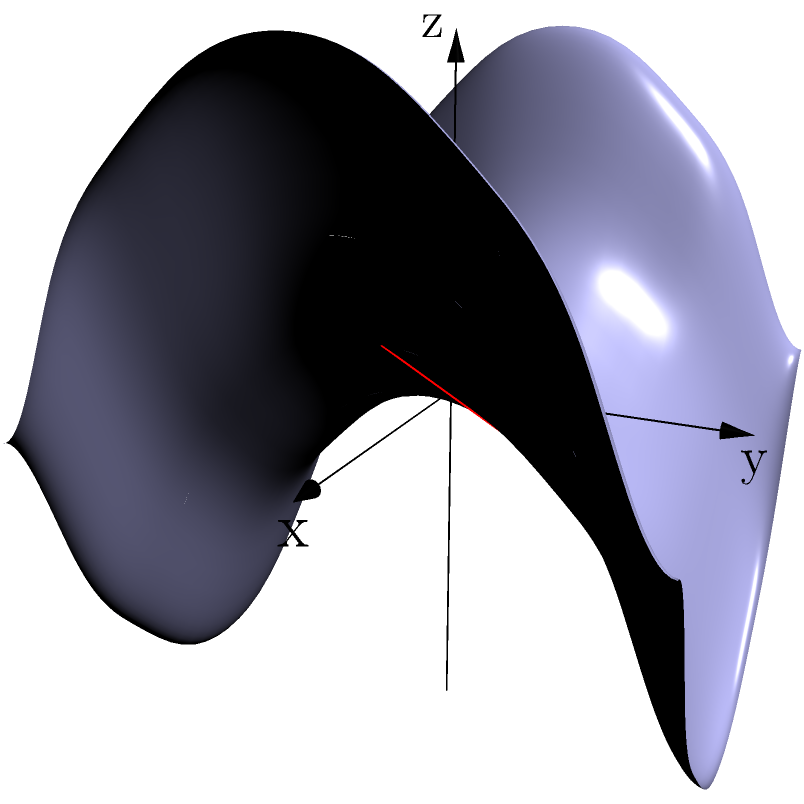On a saddle-shaped surface described by the equation $z = \frac{1}{2}(x^2 - y^2)$, a geodesic is drawn from point A(1,0,0.5) to point B(0,1,-0.5). Calculate the length of this geodesic curve. To solve this problem, we'll follow these steps:

1) The surface is defined by $z = \frac{1}{2}(x^2 - y^2)$, which is a hyperbolic paraboloid or saddle surface.

2) A geodesic on this surface is the shortest path between two points that lies entirely on the surface.

3) For a hyperbolic paraboloid, the geodesics are generally not straight lines in 3D space, but they are straight lines when projected onto the xy-plane.

4) The geodesic from A(1,0,0.5) to B(0,1,-0.5) will project as a straight line from (1,0) to (0,1) in the xy-plane.

5) We can parameterize this line as:
   $x(t) = 1-t$
   $y(t) = t$
   $z(t) = \frac{1}{2}((1-t)^2 - t^2)$
   where $0 \leq t \leq 1$

6) The length of the geodesic is given by the integral:

   $$L = \int_0^1 \sqrt{(\frac{dx}{dt})^2 + (\frac{dy}{dt})^2 + (\frac{dz}{dt})^2} dt$$

7) Calculating the derivatives:
   $\frac{dx}{dt} = -1$
   $\frac{dy}{dt} = 1$
   $\frac{dz}{dt} = -2(1-t) + 2t = 2t - 2$

8) Substituting into the integral:

   $$L = \int_0^1 \sqrt{(-1)^2 + 1^2 + (2t-2)^2} dt$$
   $$= \int_0^1 \sqrt{2 + (2t-2)^2} dt$$

9) This integral doesn't have a simple closed form solution, but it can be evaluated numerically to approximately 1.4789.

Therefore, the length of the geodesic is approximately 1.4789 units.
Answer: $\approx 1.4789$ units 